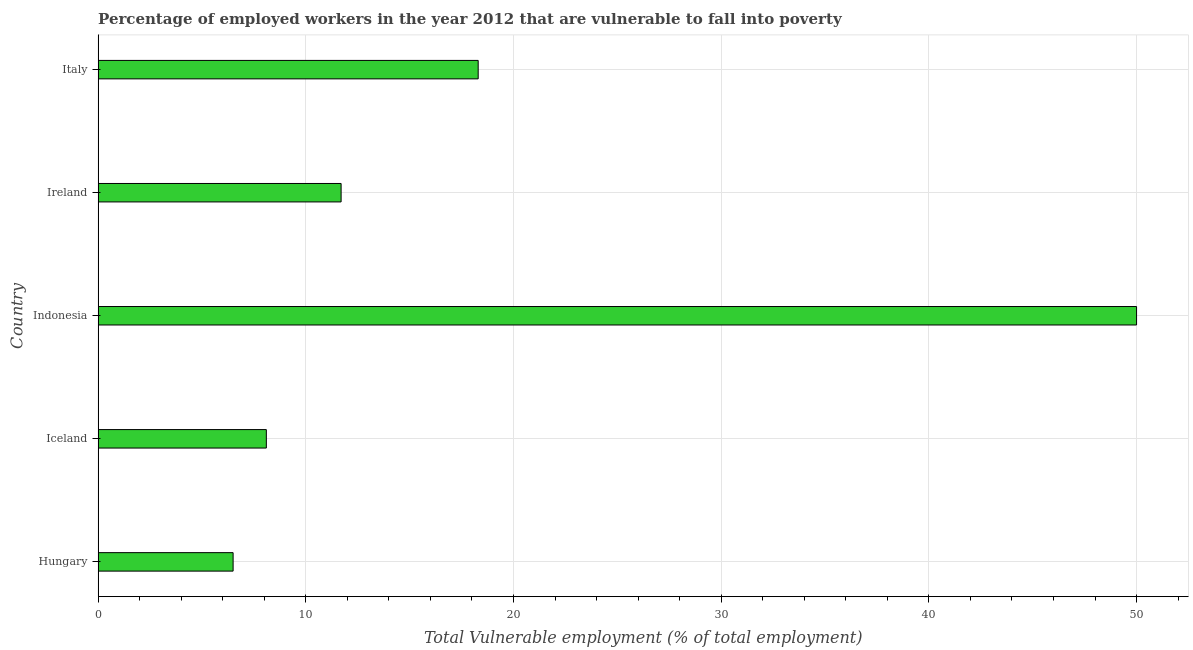What is the title of the graph?
Provide a succinct answer. Percentage of employed workers in the year 2012 that are vulnerable to fall into poverty. What is the label or title of the X-axis?
Your answer should be very brief. Total Vulnerable employment (% of total employment). What is the total vulnerable employment in Ireland?
Give a very brief answer. 11.7. Across all countries, what is the maximum total vulnerable employment?
Keep it short and to the point. 50. Across all countries, what is the minimum total vulnerable employment?
Make the answer very short. 6.5. In which country was the total vulnerable employment maximum?
Ensure brevity in your answer.  Indonesia. In which country was the total vulnerable employment minimum?
Provide a succinct answer. Hungary. What is the sum of the total vulnerable employment?
Keep it short and to the point. 94.6. What is the average total vulnerable employment per country?
Offer a terse response. 18.92. What is the median total vulnerable employment?
Your answer should be very brief. 11.7. What is the ratio of the total vulnerable employment in Indonesia to that in Ireland?
Offer a terse response. 4.27. What is the difference between the highest and the second highest total vulnerable employment?
Your answer should be compact. 31.7. Is the sum of the total vulnerable employment in Iceland and Indonesia greater than the maximum total vulnerable employment across all countries?
Keep it short and to the point. Yes. What is the difference between the highest and the lowest total vulnerable employment?
Your answer should be compact. 43.5. In how many countries, is the total vulnerable employment greater than the average total vulnerable employment taken over all countries?
Provide a succinct answer. 1. How many bars are there?
Your response must be concise. 5. Are all the bars in the graph horizontal?
Keep it short and to the point. Yes. What is the difference between two consecutive major ticks on the X-axis?
Provide a succinct answer. 10. Are the values on the major ticks of X-axis written in scientific E-notation?
Give a very brief answer. No. What is the Total Vulnerable employment (% of total employment) of Iceland?
Your response must be concise. 8.1. What is the Total Vulnerable employment (% of total employment) in Indonesia?
Offer a very short reply. 50. What is the Total Vulnerable employment (% of total employment) of Ireland?
Your answer should be very brief. 11.7. What is the Total Vulnerable employment (% of total employment) of Italy?
Provide a succinct answer. 18.3. What is the difference between the Total Vulnerable employment (% of total employment) in Hungary and Iceland?
Make the answer very short. -1.6. What is the difference between the Total Vulnerable employment (% of total employment) in Hungary and Indonesia?
Ensure brevity in your answer.  -43.5. What is the difference between the Total Vulnerable employment (% of total employment) in Hungary and Ireland?
Your answer should be very brief. -5.2. What is the difference between the Total Vulnerable employment (% of total employment) in Iceland and Indonesia?
Keep it short and to the point. -41.9. What is the difference between the Total Vulnerable employment (% of total employment) in Iceland and Italy?
Give a very brief answer. -10.2. What is the difference between the Total Vulnerable employment (% of total employment) in Indonesia and Ireland?
Offer a terse response. 38.3. What is the difference between the Total Vulnerable employment (% of total employment) in Indonesia and Italy?
Offer a very short reply. 31.7. What is the ratio of the Total Vulnerable employment (% of total employment) in Hungary to that in Iceland?
Your response must be concise. 0.8. What is the ratio of the Total Vulnerable employment (% of total employment) in Hungary to that in Indonesia?
Make the answer very short. 0.13. What is the ratio of the Total Vulnerable employment (% of total employment) in Hungary to that in Ireland?
Provide a short and direct response. 0.56. What is the ratio of the Total Vulnerable employment (% of total employment) in Hungary to that in Italy?
Your answer should be very brief. 0.35. What is the ratio of the Total Vulnerable employment (% of total employment) in Iceland to that in Indonesia?
Your answer should be very brief. 0.16. What is the ratio of the Total Vulnerable employment (% of total employment) in Iceland to that in Ireland?
Offer a terse response. 0.69. What is the ratio of the Total Vulnerable employment (% of total employment) in Iceland to that in Italy?
Provide a succinct answer. 0.44. What is the ratio of the Total Vulnerable employment (% of total employment) in Indonesia to that in Ireland?
Keep it short and to the point. 4.27. What is the ratio of the Total Vulnerable employment (% of total employment) in Indonesia to that in Italy?
Keep it short and to the point. 2.73. What is the ratio of the Total Vulnerable employment (% of total employment) in Ireland to that in Italy?
Offer a terse response. 0.64. 